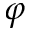<formula> <loc_0><loc_0><loc_500><loc_500>\varphi</formula> 